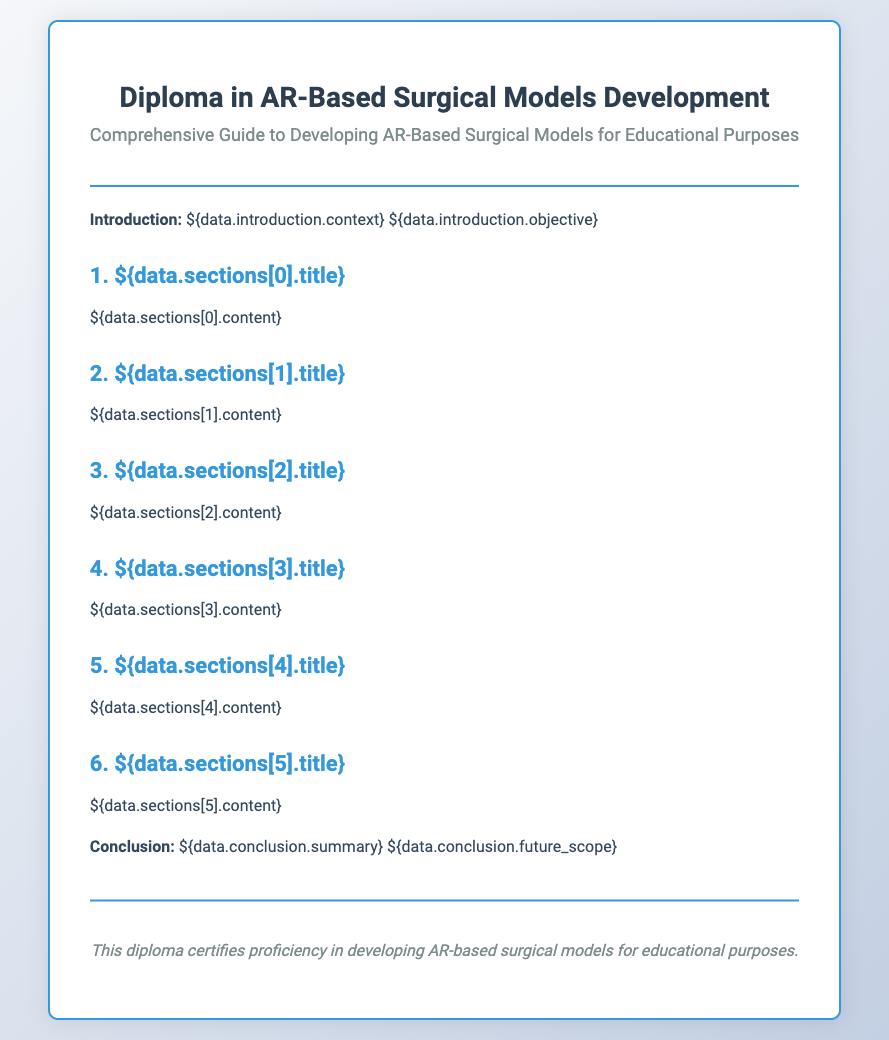What is the title of the diploma? The title of the diploma is the main heading of the document.
Answer: Diploma in AR-Based Surgical Models Development What is the subtitle of the diploma? The subtitle provides additional context about the diploma's focus.
Answer: Comprehensive Guide to Developing AR-Based Surgical Models for Educational Purposes What is included in the introduction section? The introduction contains specific components related to the document's purpose.
Answer: context and objective How many sections are in the diploma? The number of sections indicates the depth and coverage of the content.
Answer: Six What type of educational purposes does this diploma focus on? This specifies the application of the AR-based surgical models developed in the document.
Answer: Educational Purposes What does the footer of the diploma certify? The footer contains a statement summarizing the diploma's intent and purpose.
Answer: proficiency in developing AR-based surgical models for educational purposes What color scheme is used in the diploma design? The color scheme highlights the overall aesthetic and professionalism of the document.
Answer: Blue and white What is the content format used in each section? The content format describes how the information is structured in the diploma.
Answer: Title followed by descriptive paragraphs 